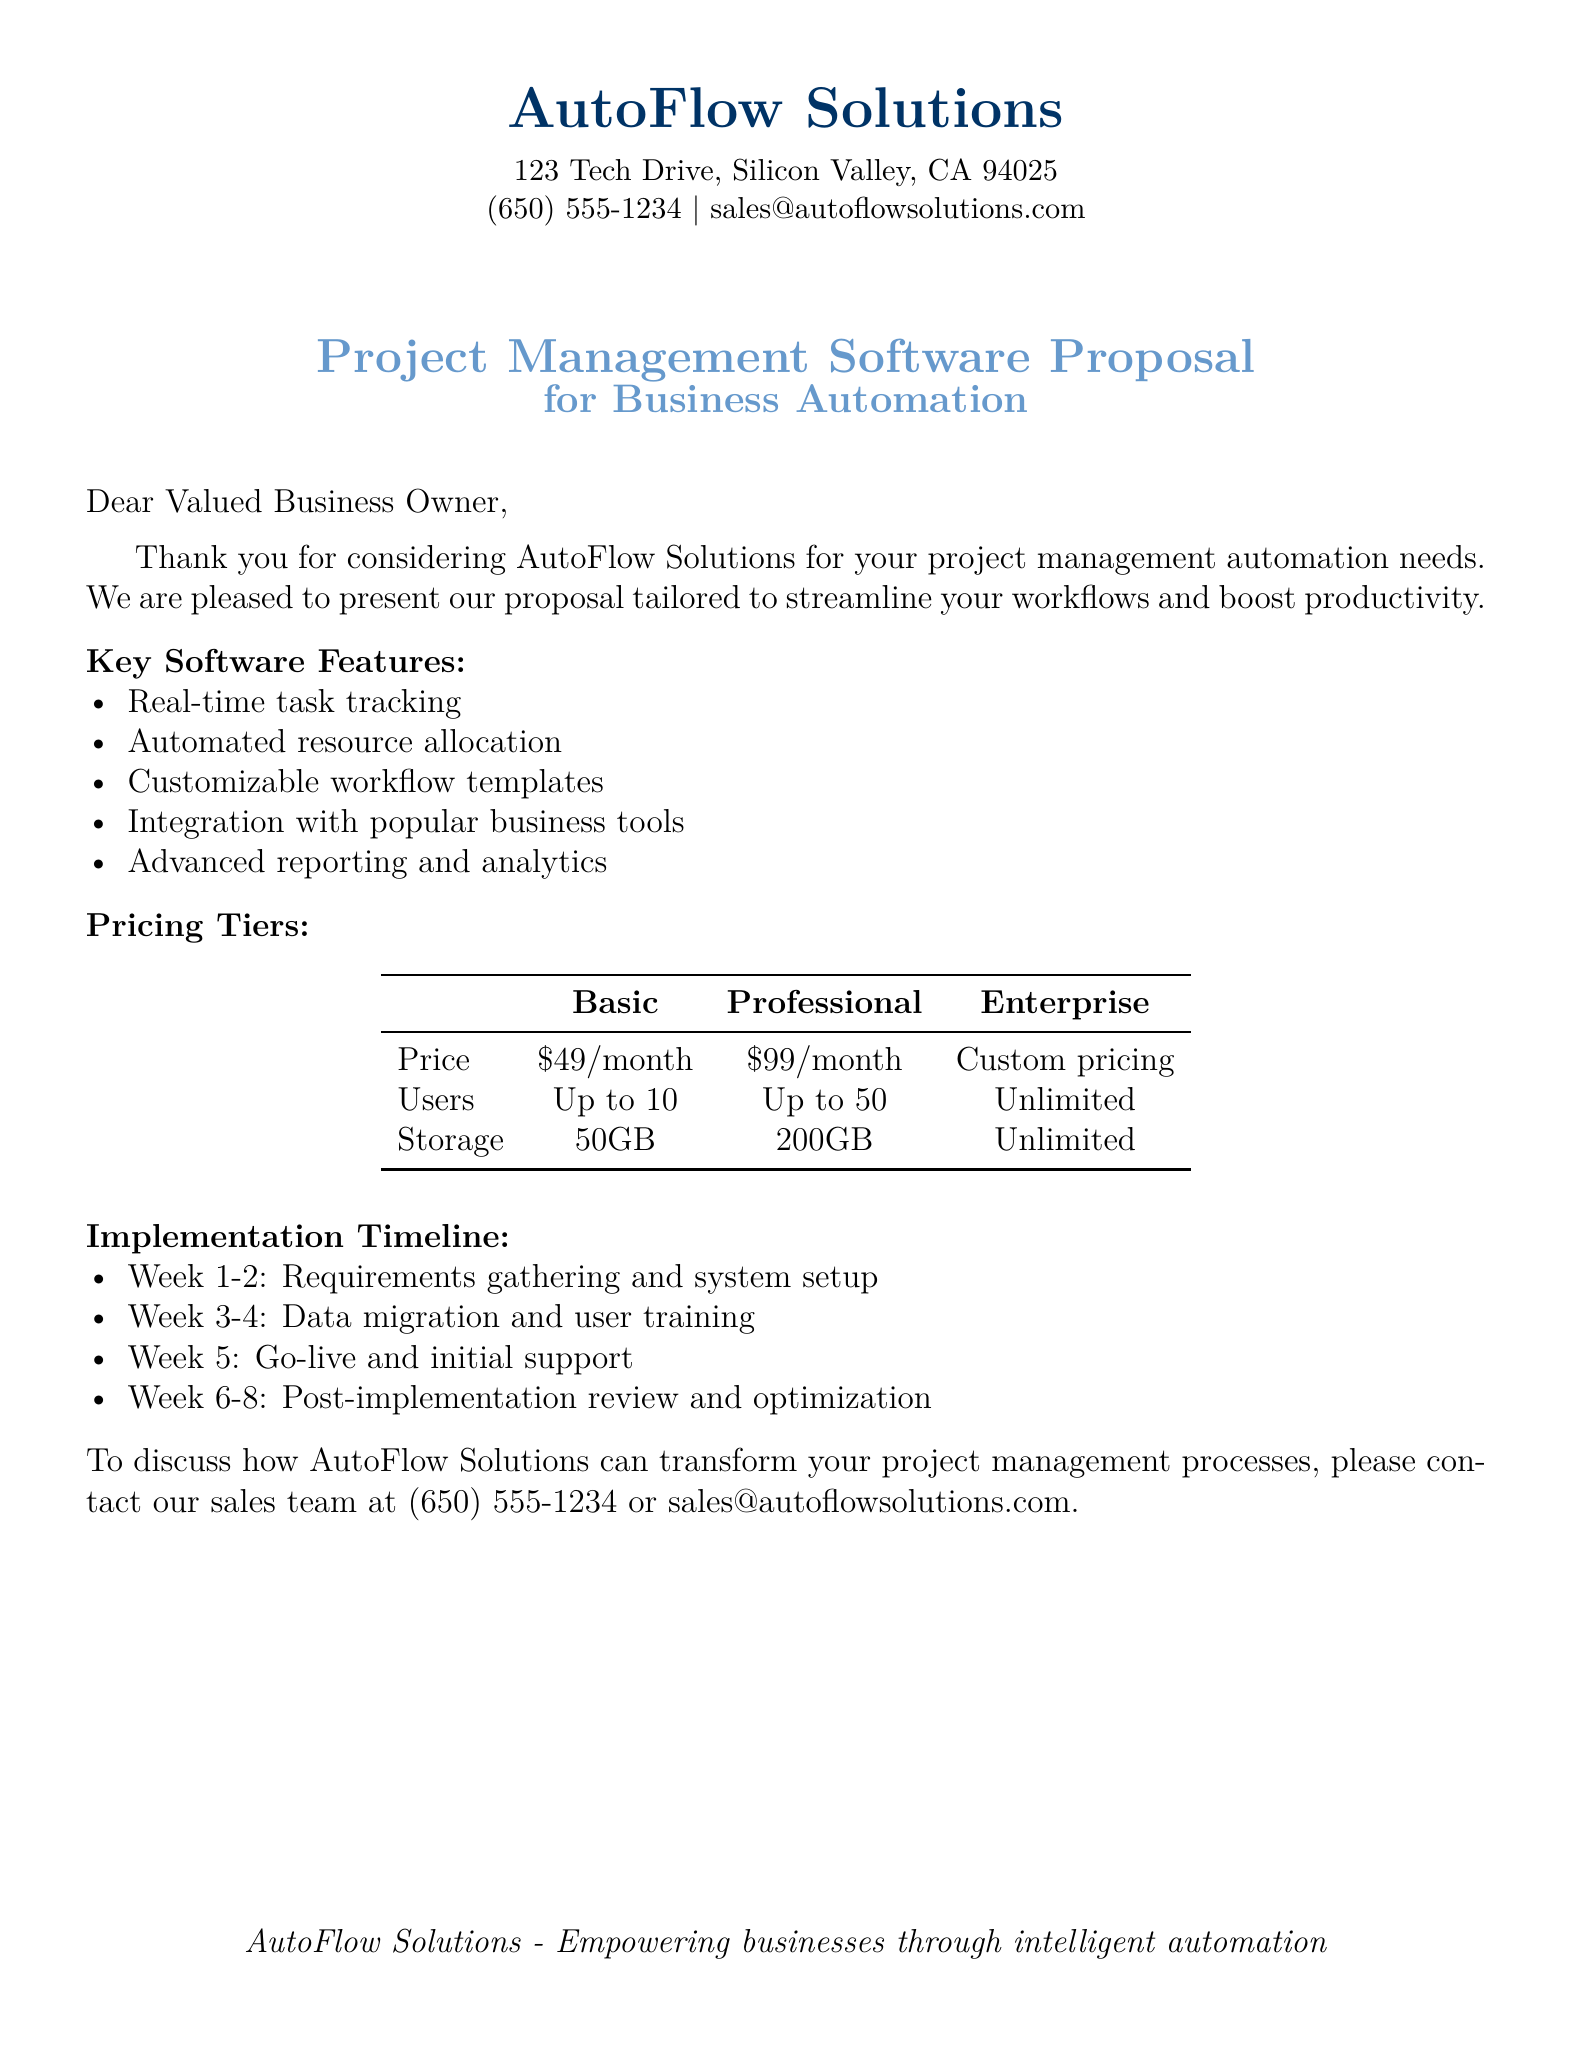what are the key software features? The document lists five key features: real-time task tracking, automated resource allocation, customizable workflow templates, integration with popular business tools, and advanced reporting and analytics.
Answer: real-time task tracking, automated resource allocation, customizable workflow templates, integration with popular business tools, advanced reporting and analytics what is the price of the Professional tier? The Professional tier is listed under the Pricing Tiers section, showing its monthly cost.
Answer: $99/month how many users can the Basic tier accommodate? The Basic tier user limit is specified in the Pricing Tiers table in the document.
Answer: Up to 10 what is the implementation timeline for data migration? The document outlines specific tasks in the implementation timeline, indicating when data migration occurs.
Answer: Week 3-4 what is the storage limit for the Professional tier? The storage limit for the Professional tier is provided in the Pricing Tiers table.
Answer: 200GB how long does the post-implementation review last? The document describes the duration of post-implementation review in the Implementation Timeline section.
Answer: 2 weeks what is the contact number for the sales team? The contact information for the sales team is included at the end of the document.
Answer: (650) 555-1234 what tier is priced with custom pricing? The Pricing Tiers table specifies the tier that does not have a fixed price.
Answer: Enterprise 